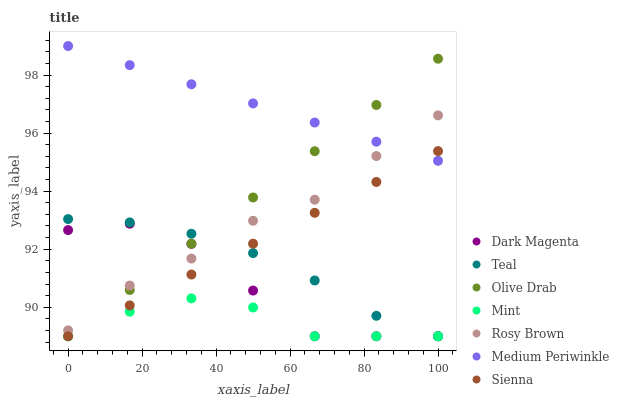Does Mint have the minimum area under the curve?
Answer yes or no. Yes. Does Medium Periwinkle have the maximum area under the curve?
Answer yes or no. Yes. Does Rosy Brown have the minimum area under the curve?
Answer yes or no. No. Does Rosy Brown have the maximum area under the curve?
Answer yes or no. No. Is Olive Drab the smoothest?
Answer yes or no. Yes. Is Dark Magenta the roughest?
Answer yes or no. Yes. Is Rosy Brown the smoothest?
Answer yes or no. No. Is Rosy Brown the roughest?
Answer yes or no. No. Does Dark Magenta have the lowest value?
Answer yes or no. Yes. Does Rosy Brown have the lowest value?
Answer yes or no. No. Does Medium Periwinkle have the highest value?
Answer yes or no. Yes. Does Rosy Brown have the highest value?
Answer yes or no. No. Is Teal less than Medium Periwinkle?
Answer yes or no. Yes. Is Rosy Brown greater than Mint?
Answer yes or no. Yes. Does Mint intersect Olive Drab?
Answer yes or no. Yes. Is Mint less than Olive Drab?
Answer yes or no. No. Is Mint greater than Olive Drab?
Answer yes or no. No. Does Teal intersect Medium Periwinkle?
Answer yes or no. No. 